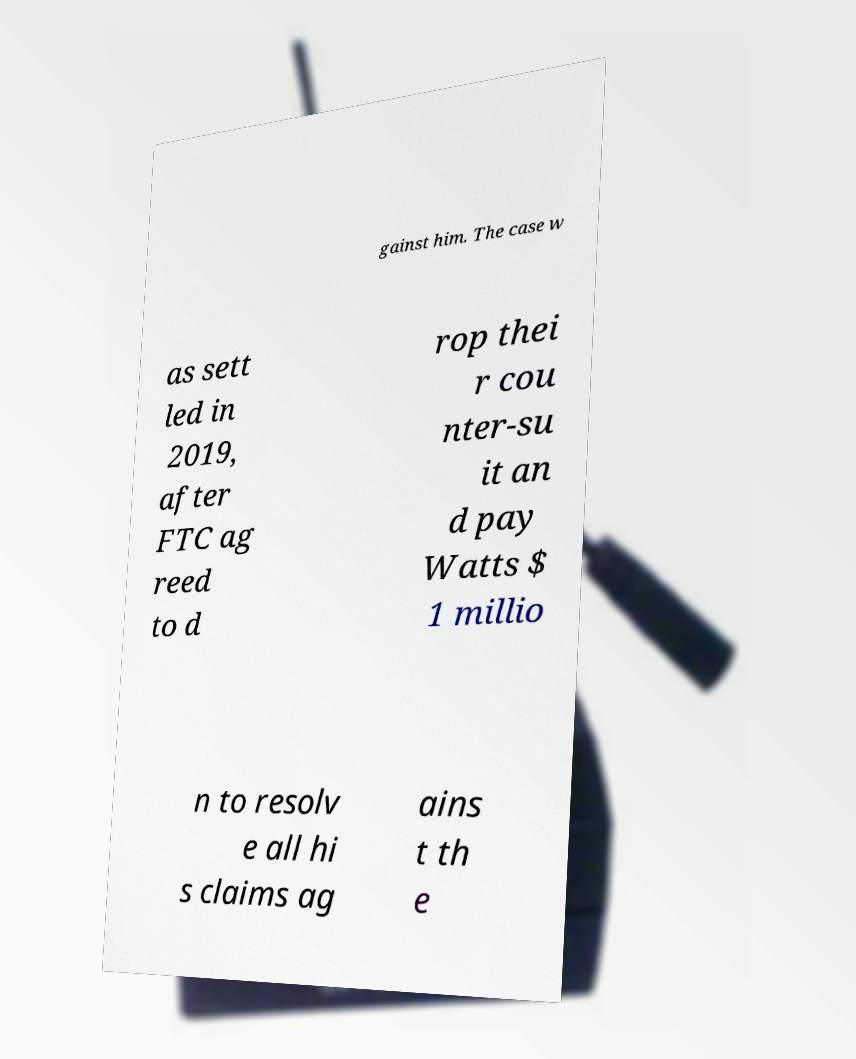Can you read and provide the text displayed in the image?This photo seems to have some interesting text. Can you extract and type it out for me? gainst him. The case w as sett led in 2019, after FTC ag reed to d rop thei r cou nter-su it an d pay Watts $ 1 millio n to resolv e all hi s claims ag ains t th e 